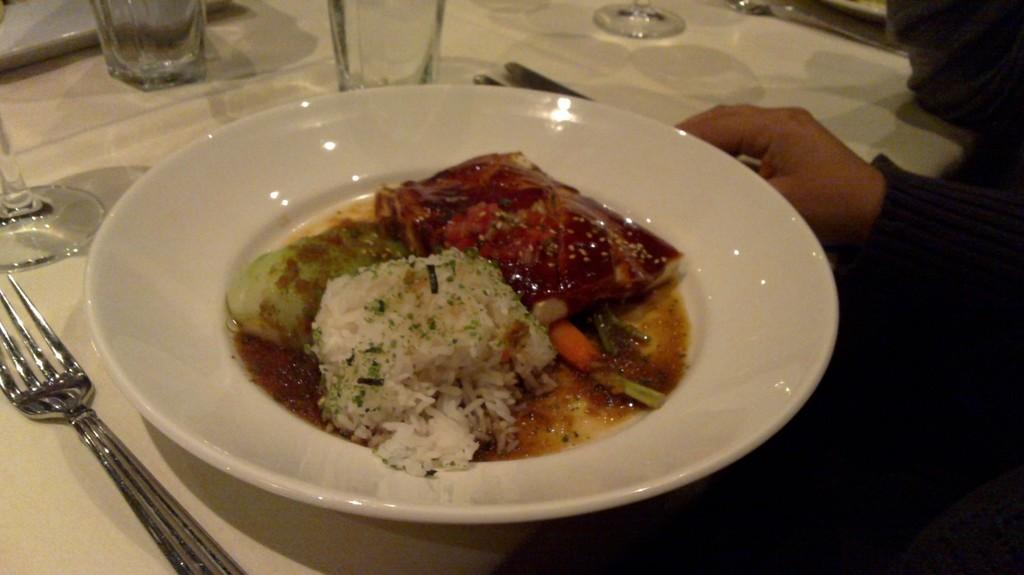Can you describe this image briefly? In this image we can see a plate containing food, group of fork, spoons and some glasses are placed on the table. On the right side of the image we can see the hand of a person. 